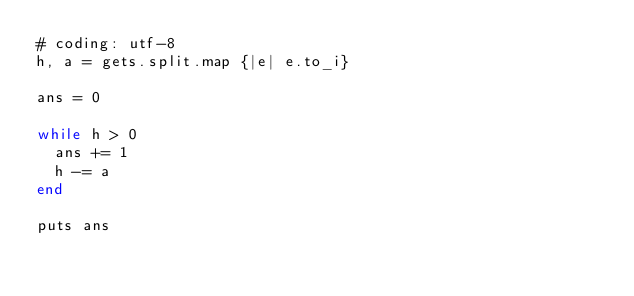<code> <loc_0><loc_0><loc_500><loc_500><_Ruby_># coding: utf-8
h, a = gets.split.map {|e| e.to_i}

ans = 0

while h > 0
  ans += 1
  h -= a
end

puts ans
</code> 